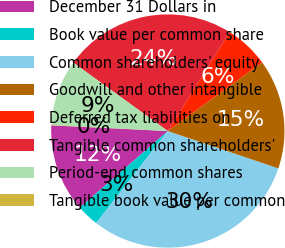Convert chart. <chart><loc_0><loc_0><loc_500><loc_500><pie_chart><fcel>December 31 Dollars in<fcel>Book value per common share<fcel>Common shareholders' equity<fcel>Goodwill and other intangible<fcel>Deferred tax liabilities on<fcel>Tangible common shareholders'<fcel>Period-end common shares<fcel>Tangible book value per common<nl><fcel>12.17%<fcel>3.08%<fcel>30.34%<fcel>15.2%<fcel>6.11%<fcel>23.91%<fcel>9.14%<fcel>0.05%<nl></chart> 